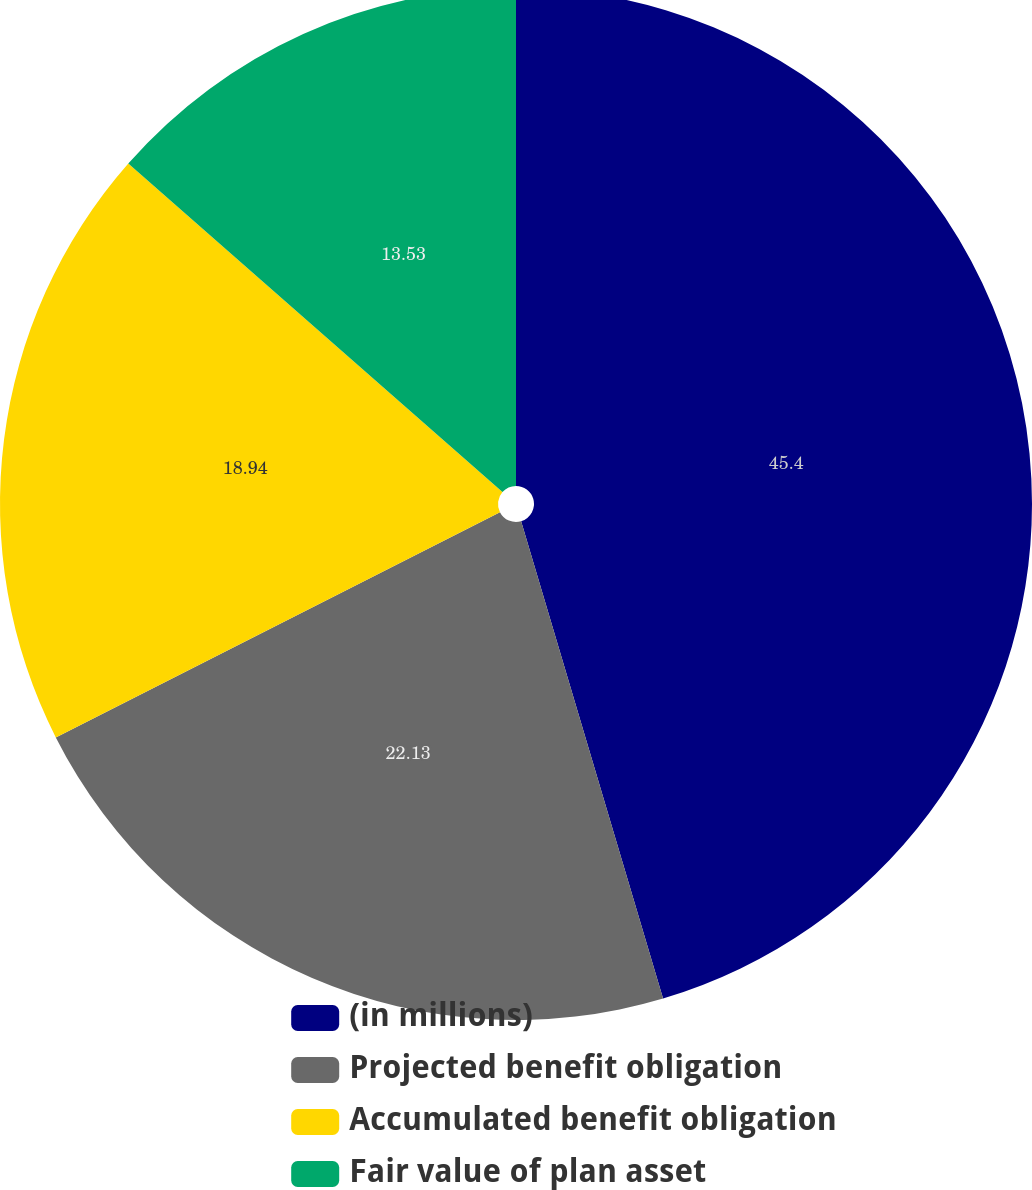Convert chart to OTSL. <chart><loc_0><loc_0><loc_500><loc_500><pie_chart><fcel>(in millions)<fcel>Projected benefit obligation<fcel>Accumulated benefit obligation<fcel>Fair value of plan asset<nl><fcel>45.4%<fcel>22.13%<fcel>18.94%<fcel>13.53%<nl></chart> 